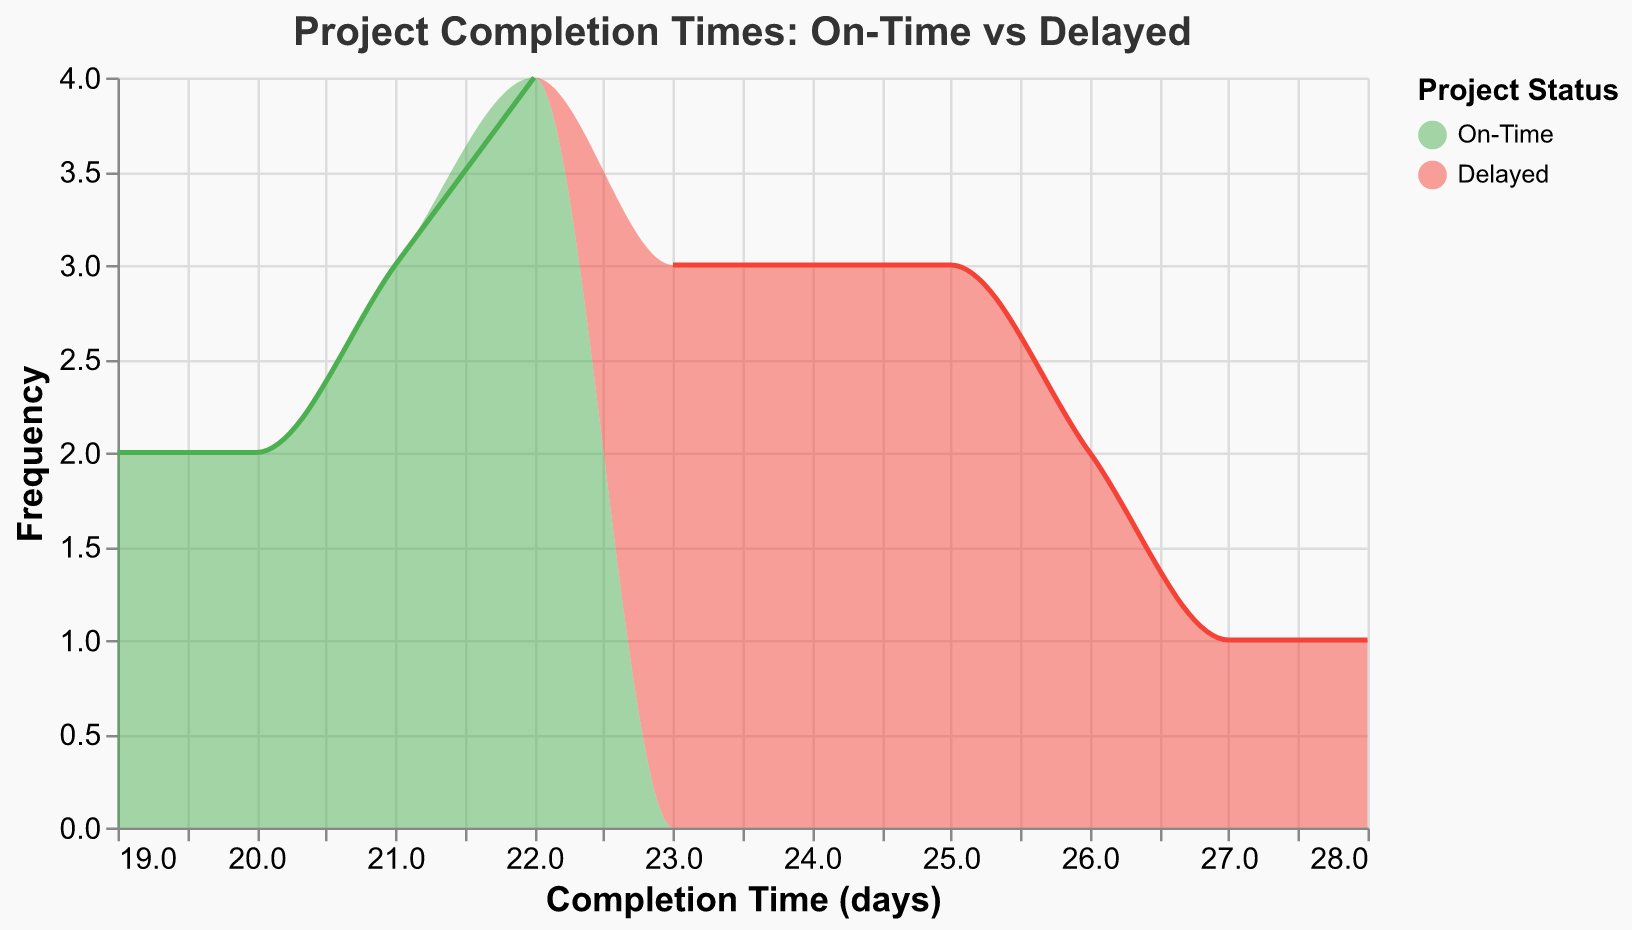What is the title of the plot? The title of the plot is located at the top of the chart. It clearly states the main theme of the figure.
Answer: Project Completion Times: On-Time vs Delayed Which color represents "On-Time" projects? The color legend on the right side of the plot shows the mapping between project status and colors. The "On-Time" status is associated with a green color.
Answer: Green How many projects were completed in 22 days? To find this, locate the x-axis value of 22 days. Then, see the height of the areas representing both "On-Time" and "Delayed" projects at this point on the y-axis.
Answer: Five What's the peak frequency for "On-Time" projects? Look at the green area on the plot to see where it reaches its highest point on the y-axis. This tallest point represents the peak frequency of "On-Time" projects.
Answer: Five Which completion time has the highest frequency of delayed projects? Check the red area of the plot to find where it peaks, meaning where the frequency of delayed projects is the highest, and look down to the x-axis for the corresponding completion time.
Answer: 24 days Compare the completion times between "On-Time" and "Delayed" projects. Which category generally has longer completion times? Compare the horizontal spread of green areas (representing "On-Time") and red areas (representing "Delayed"). The red areas extend to higher completion times, indicating delayed projects generally take longer.
Answer: Delayed projects What's the trend observed as completion time increases, in the context of on-time versus delayed submissions? Observe the shape of the plot areas for both "On-Time" and "Delayed" projects as completion time increases. There are fewer "On-Time" projects as completion times go up, whereas "Delayed" projects tend to be more frequent at higher completion times.
Answer: More delays occur as completion time increases 